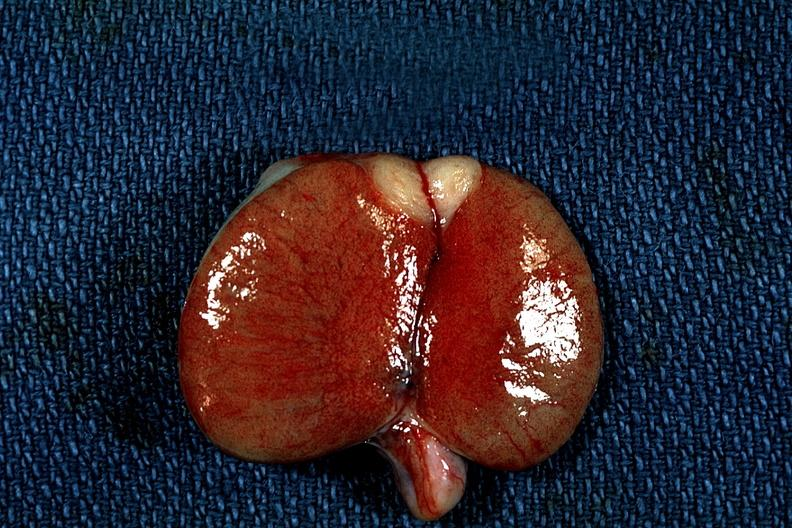does digital infarcts bacterial endocarditis show discrete tumor mass?
Answer the question using a single word or phrase. No 